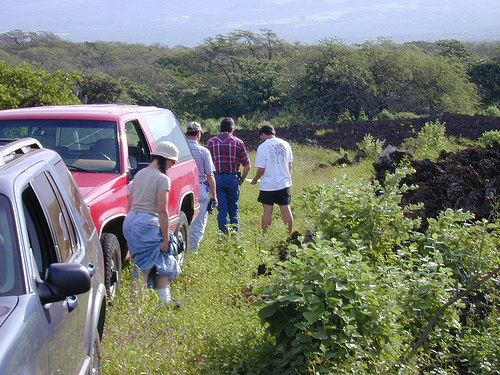<image>
Can you confirm if the girl is in the truck? No. The girl is not contained within the truck. These objects have a different spatial relationship. 